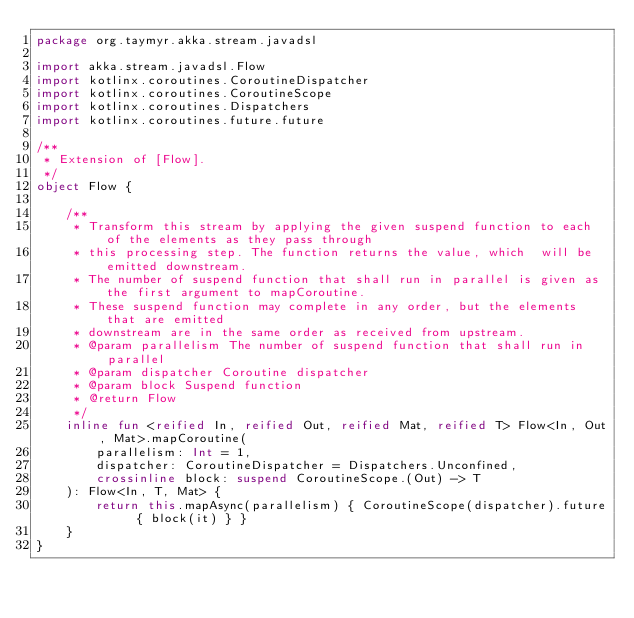Convert code to text. <code><loc_0><loc_0><loc_500><loc_500><_Kotlin_>package org.taymyr.akka.stream.javadsl

import akka.stream.javadsl.Flow
import kotlinx.coroutines.CoroutineDispatcher
import kotlinx.coroutines.CoroutineScope
import kotlinx.coroutines.Dispatchers
import kotlinx.coroutines.future.future

/**
 * Extension of [Flow].
 */
object Flow {

    /**
     * Transform this stream by applying the given suspend function to each of the elements as they pass through
     * this processing step. The function returns the value, which  will be emitted downstream.
     * The number of suspend function that shall run in parallel is given as the first argument to mapCoroutine.
     * These suspend function may complete in any order, but the elements that are emitted
     * downstream are in the same order as received from upstream.
     * @param parallelism The number of suspend function that shall run in parallel
     * @param dispatcher Coroutine dispatcher
     * @param block Suspend function
     * @return Flow
     */
    inline fun <reified In, reified Out, reified Mat, reified T> Flow<In, Out, Mat>.mapCoroutine(
        parallelism: Int = 1,
        dispatcher: CoroutineDispatcher = Dispatchers.Unconfined,
        crossinline block: suspend CoroutineScope.(Out) -> T
    ): Flow<In, T, Mat> {
        return this.mapAsync(parallelism) { CoroutineScope(dispatcher).future { block(it) } }
    }
}
</code> 